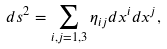<formula> <loc_0><loc_0><loc_500><loc_500>d s ^ { 2 } = \sum _ { i , j = 1 , 3 } \eta _ { i j } d x ^ { i } d x ^ { j } ,</formula> 